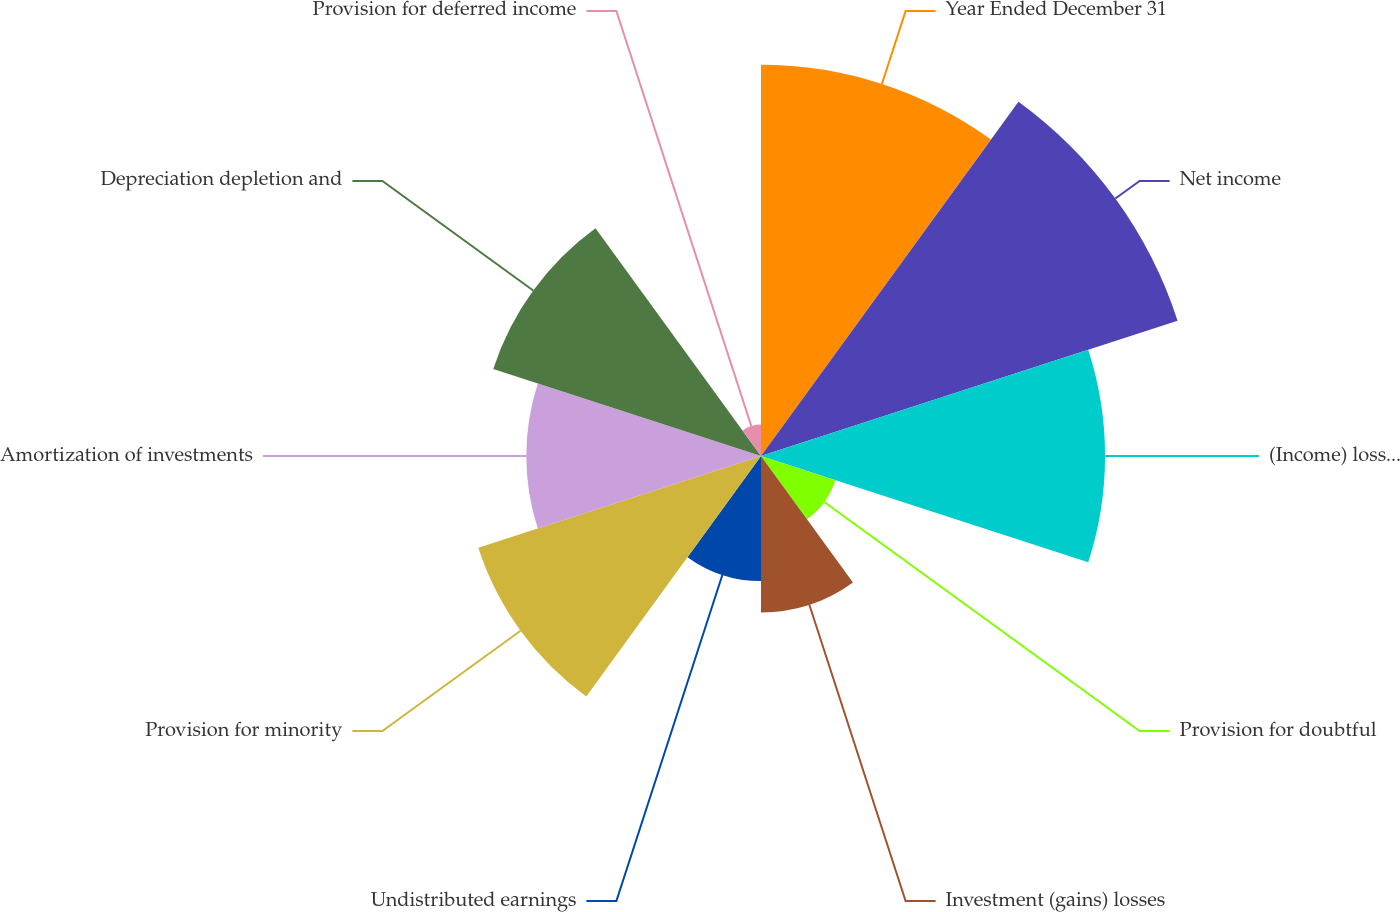<chart> <loc_0><loc_0><loc_500><loc_500><pie_chart><fcel>Year Ended December 31<fcel>Net income<fcel>(Income) loss from<fcel>Provision for doubtful<fcel>Investment (gains) losses<fcel>Undistributed earnings<fcel>Provision for minority<fcel>Amortization of investments<fcel>Depreciation depletion and<fcel>Provision for deferred income<nl><fcel>16.45%<fcel>18.42%<fcel>14.47%<fcel>3.29%<fcel>6.58%<fcel>5.26%<fcel>12.5%<fcel>9.87%<fcel>11.84%<fcel>1.32%<nl></chart> 